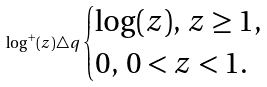Convert formula to latex. <formula><loc_0><loc_0><loc_500><loc_500>\log ^ { + } ( z ) \triangle q \begin{cases} \log ( z ) , \, z \geq 1 , \\ 0 , \, 0 < z < 1 . \end{cases}</formula> 